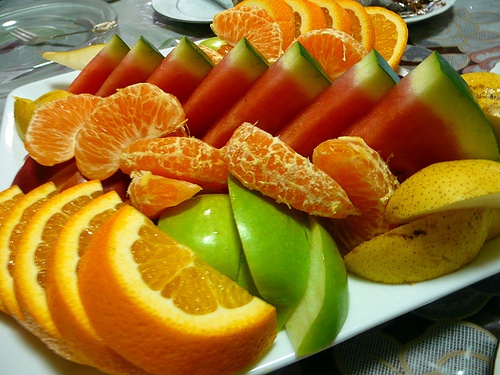Describe the objects in this image and their specific colors. I can see orange in black, orange, red, and khaki tones, orange in black, red, and orange tones, dining table in black, gray, and darkgray tones, orange in black, red, orange, and gold tones, and orange in black, brown, orange, and khaki tones in this image. 